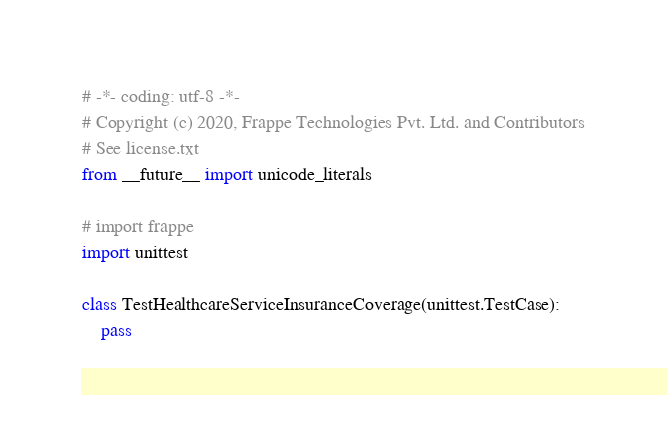Convert code to text. <code><loc_0><loc_0><loc_500><loc_500><_Python_># -*- coding: utf-8 -*-
# Copyright (c) 2020, Frappe Technologies Pvt. Ltd. and Contributors
# See license.txt
from __future__ import unicode_literals

# import frappe
import unittest

class TestHealthcareServiceInsuranceCoverage(unittest.TestCase):
	pass
</code> 